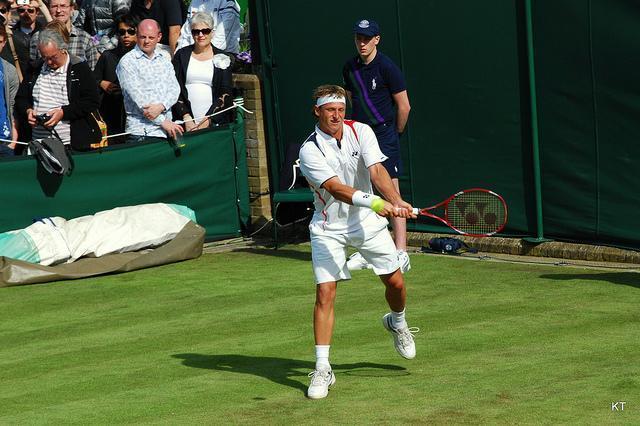How many people are in the picture?
Give a very brief answer. 7. 